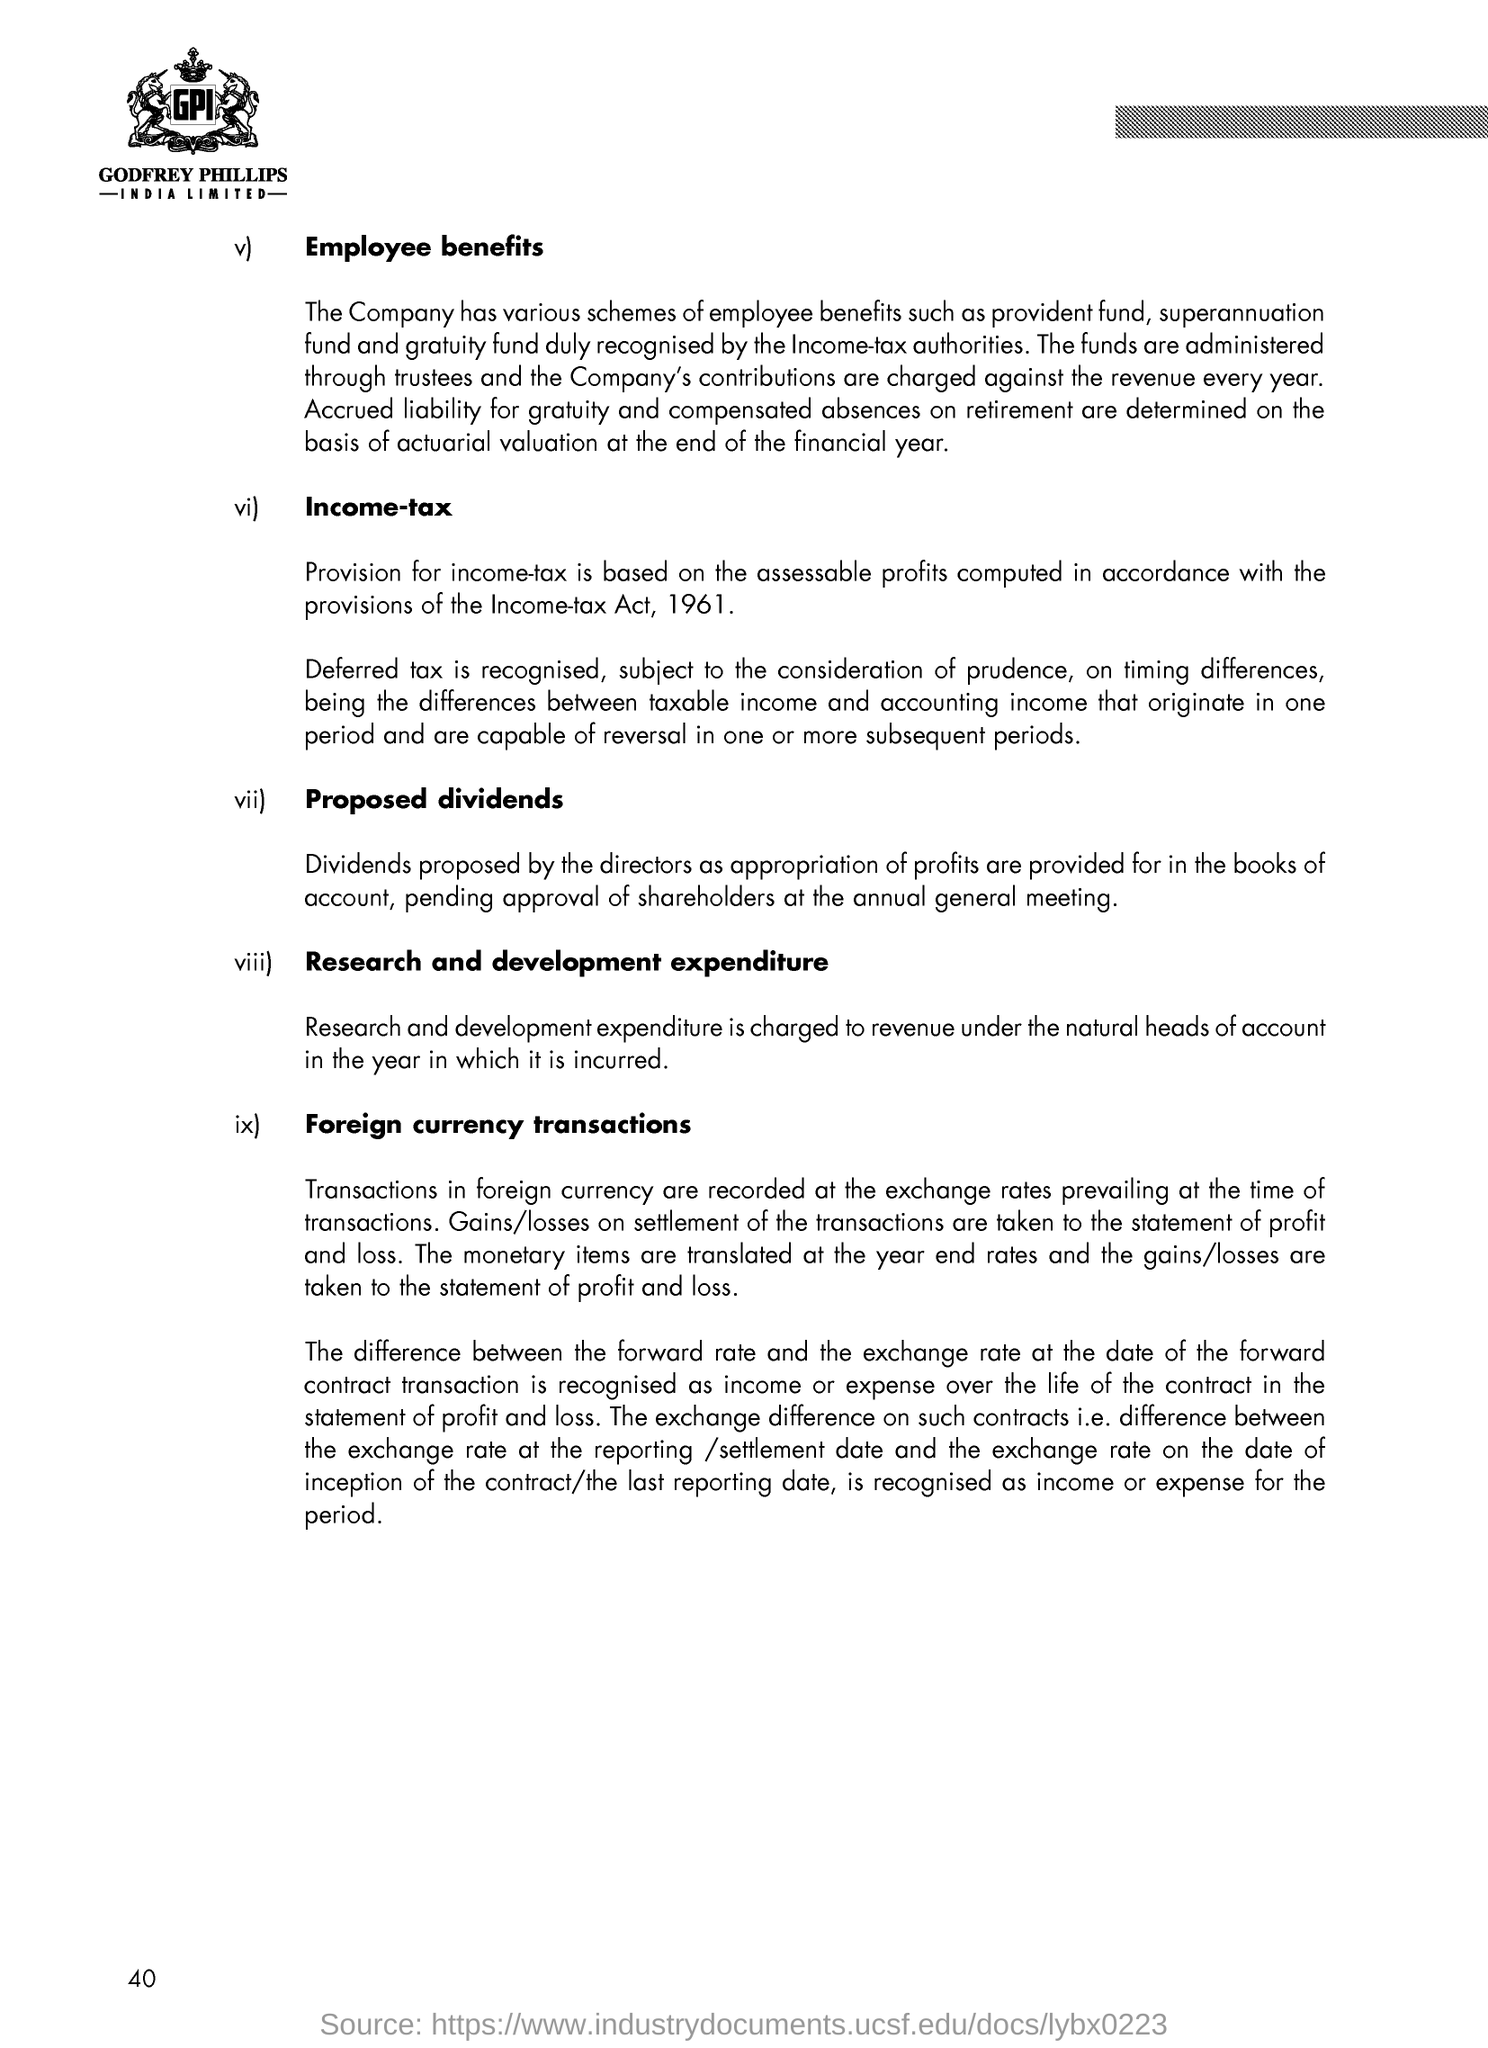Explain the company's approach to research and development expenditure. The document indicates that research and development expenditure is charged to revenue under the natural heads of account in the year it is incurred. This means that the company expenses R&D costs as they occur, reflecting a commitment to investing in innovation and improvement of their products or services within each financial year. 